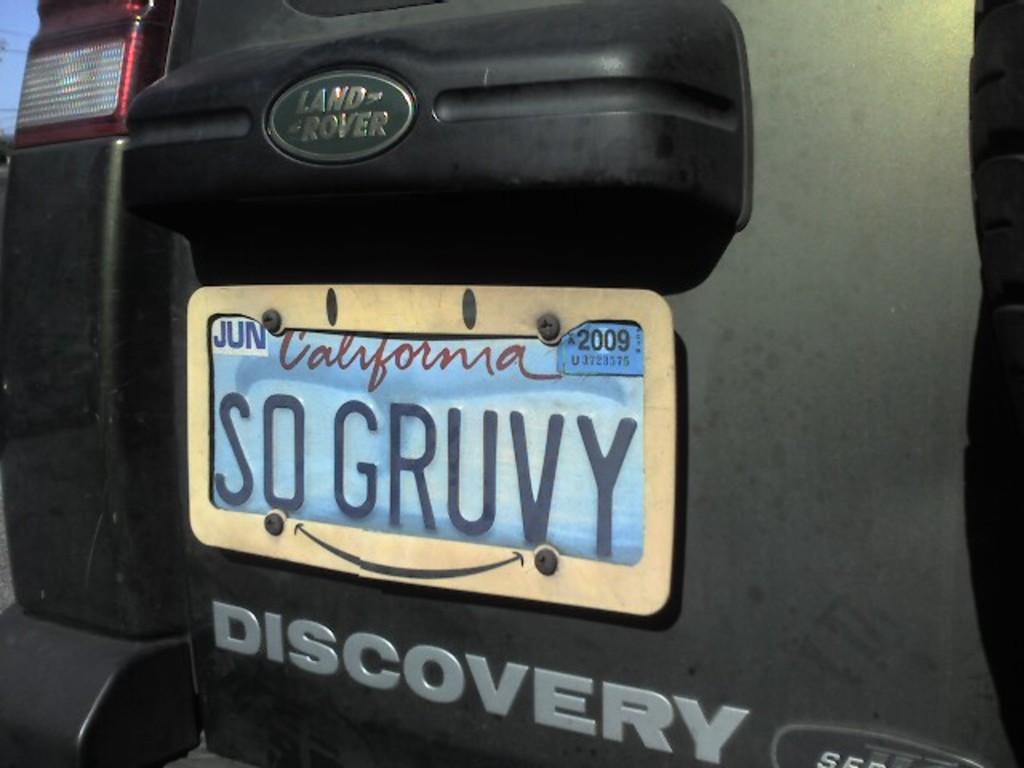What state is the car registered in?
Offer a terse response. California. 